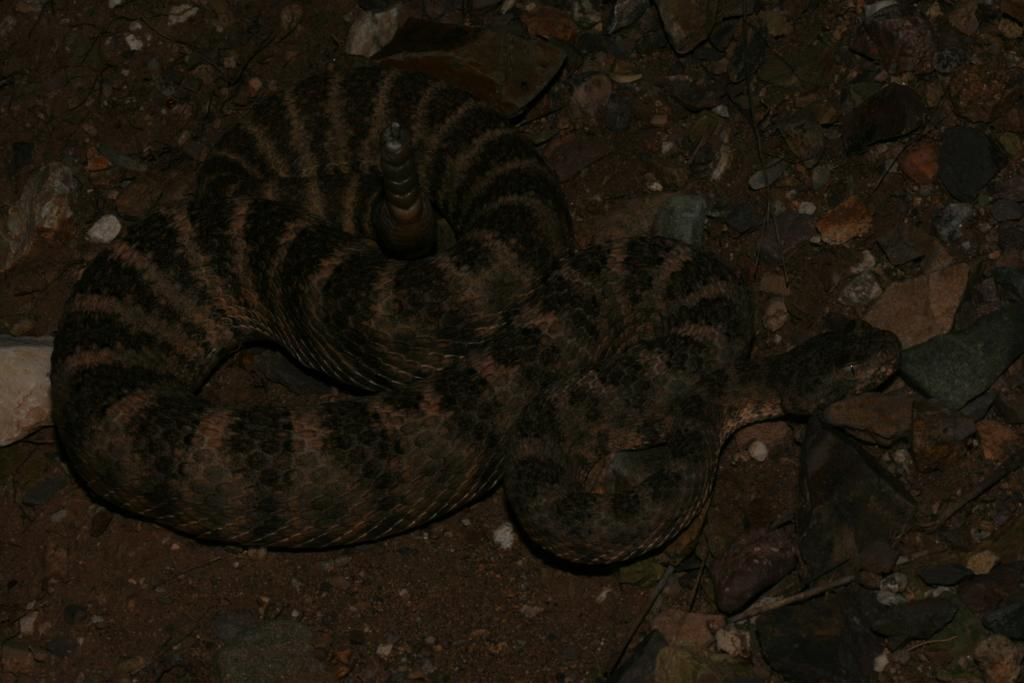What type of animal is present in the image? There is a snake in the image. What can be seen on the ground in the image? There are stones on the ground in the image. What type of metal object can be seen in the image? There is no metal object present in the image. What type of songs can be heard being sung by the snake in the image? There are no songs being sung by the snake in the image, as snakes do not have the ability to sing. 